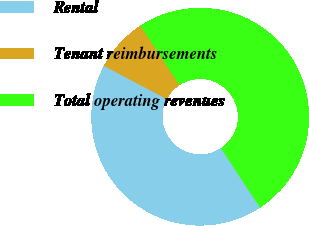<chart> <loc_0><loc_0><loc_500><loc_500><pie_chart><fcel>Rental<fcel>Tenant reimbursements<fcel>Total operating revenues<nl><fcel>41.99%<fcel>8.01%<fcel>50.0%<nl></chart> 